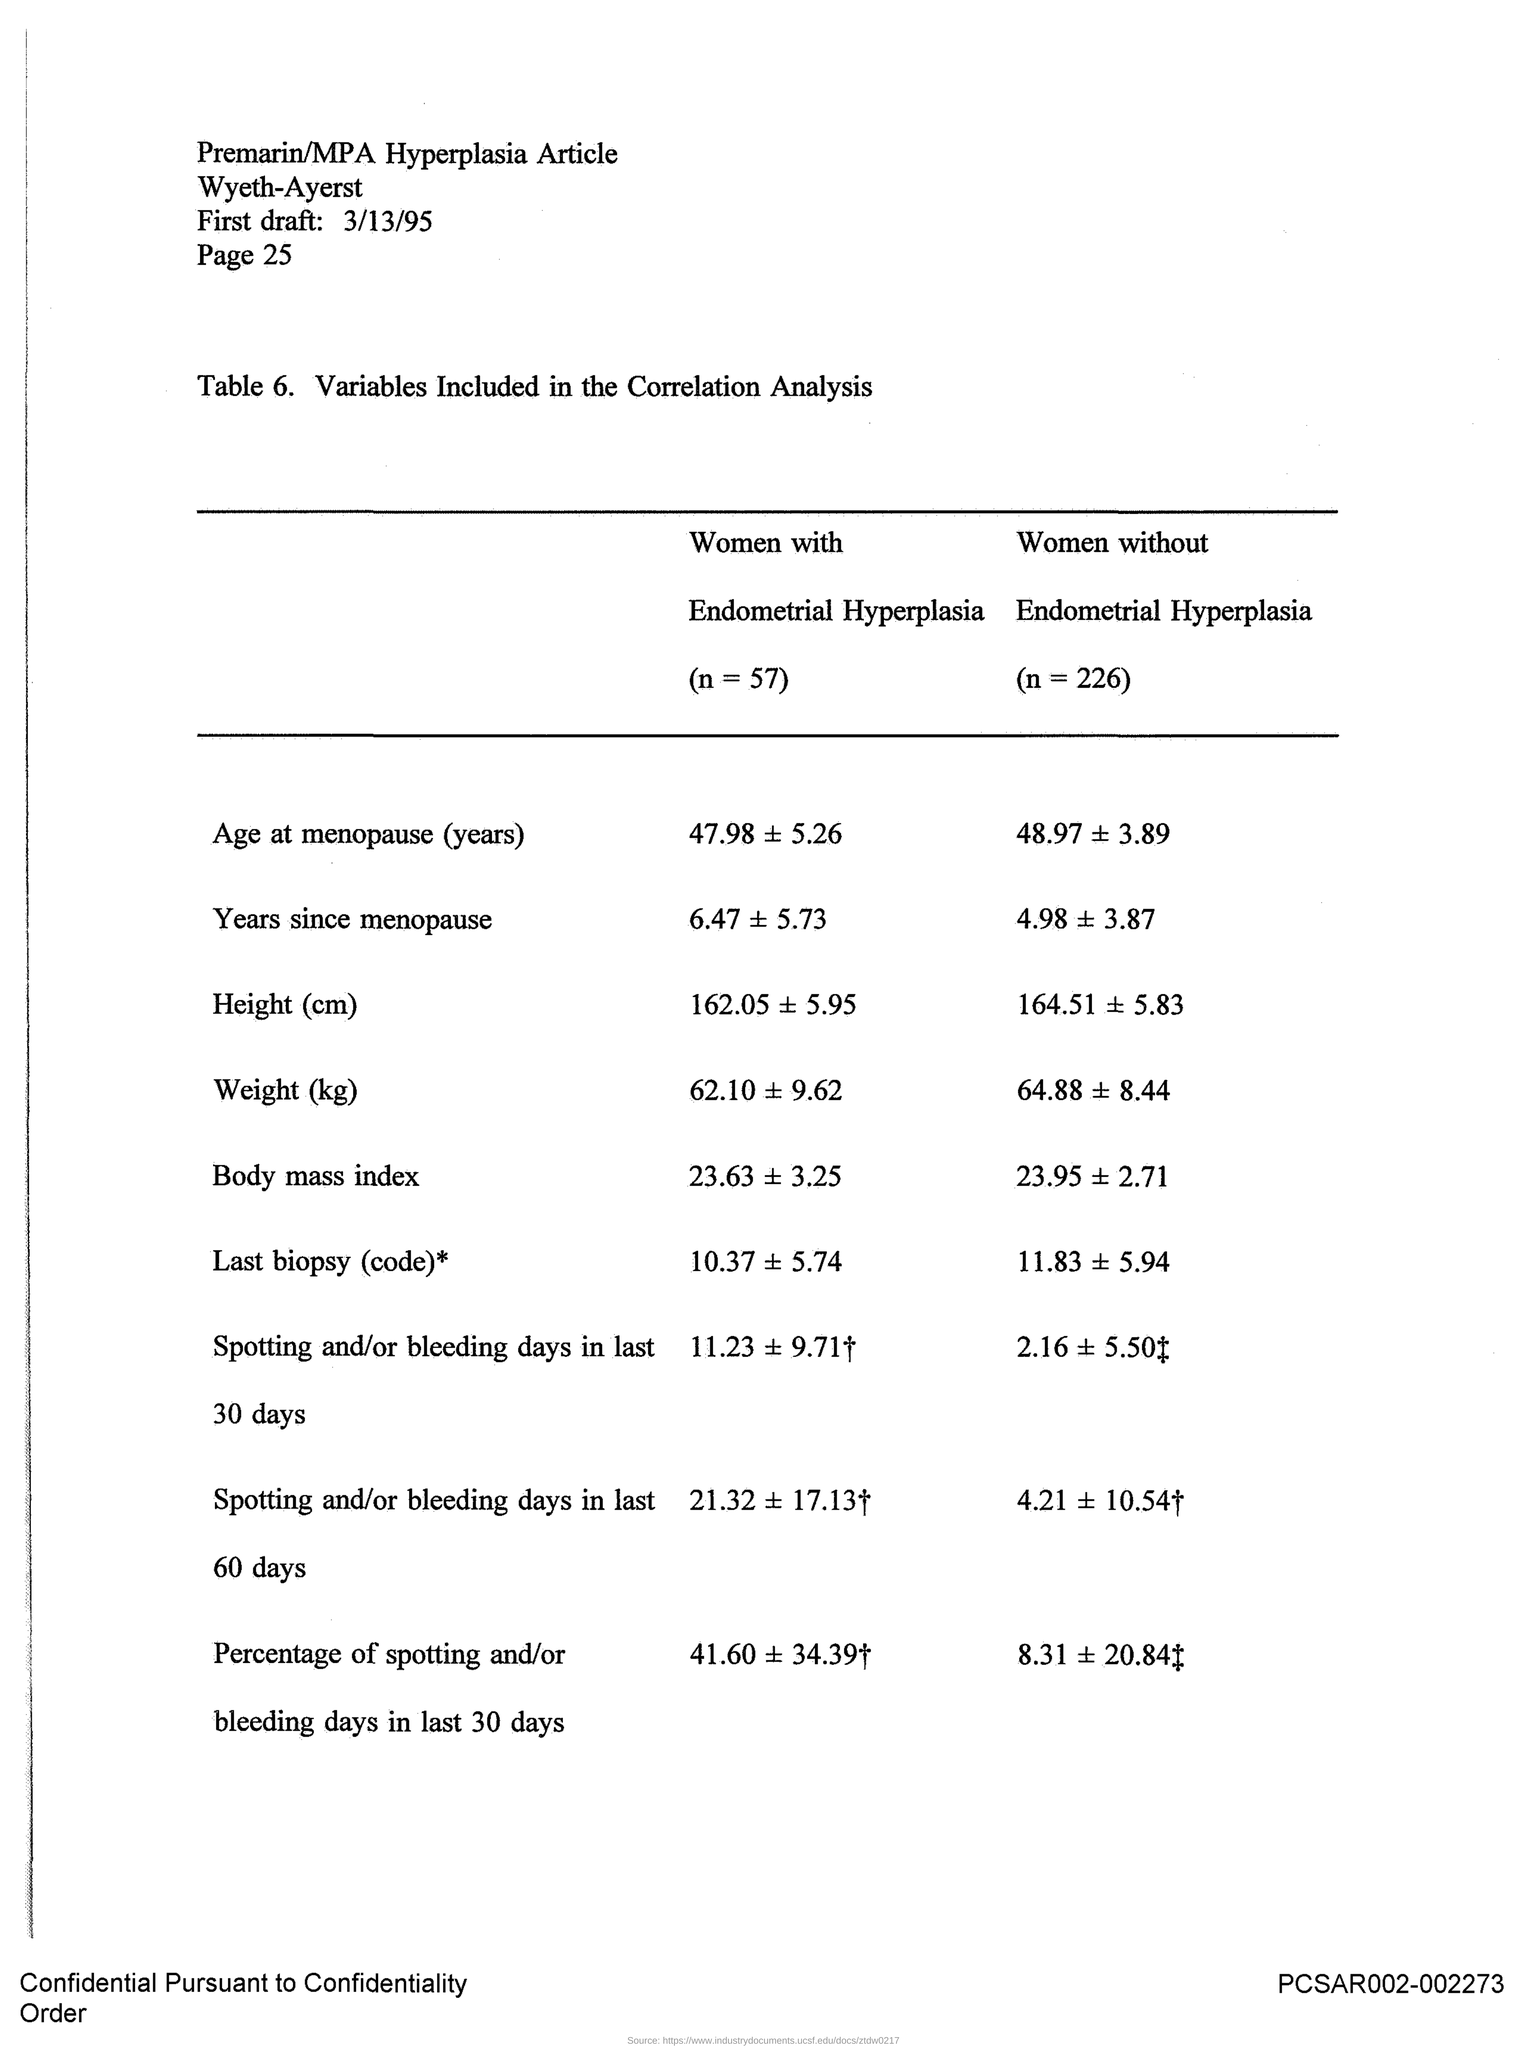What is the date mentioned in the given draft ?
Your response must be concise. 3/13/95. 